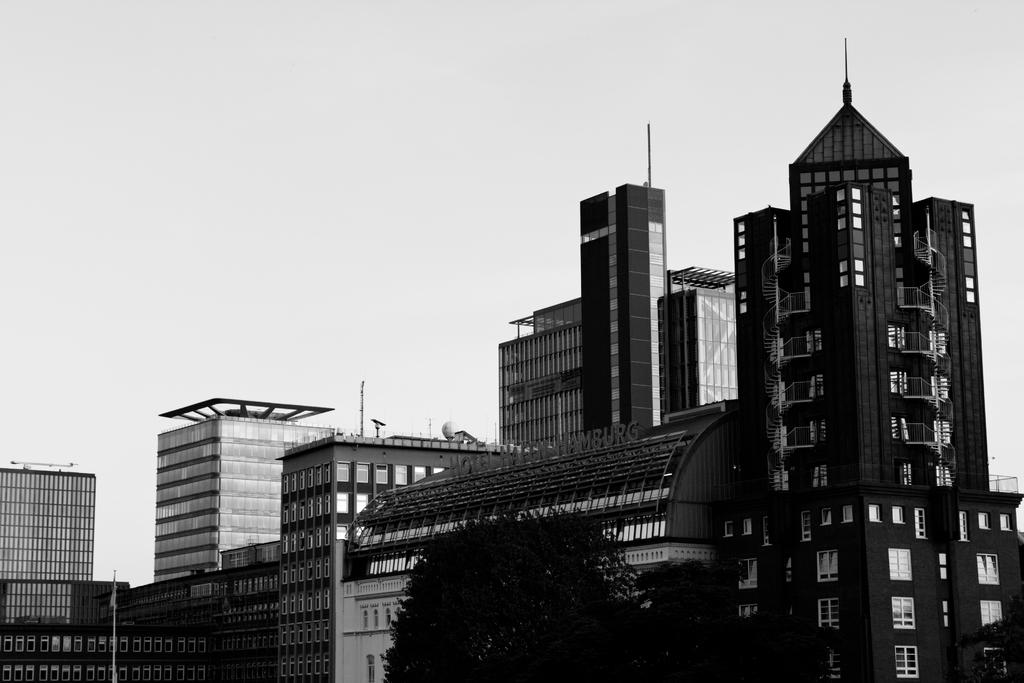What type of natural elements can be seen in the image? There are trees in the image. What type of man-made structures are present in the image? There are buildings in the image. What part of the natural environment is visible in the image? The sky is visible in the image. What is the color scheme of the image? The image is in black and white. Can you tell me how many volleyballs are visible in the image? There are no volleyballs present in the image. What type of secretary is shown working in the image? There is no secretary present in the image. 